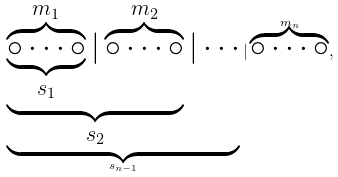Convert formula to latex. <formula><loc_0><loc_0><loc_500><loc_500>\underbrace { \underbrace { \underbrace { \overbrace { \circ \cdots \circ } ^ { m _ { 1 } } } _ { s _ { 1 } } | \overbrace { \circ \cdots \circ } ^ { m _ { 2 } } } _ { s _ { 2 } } | \cdots } _ { s _ { n - 1 } } | \overbrace { \circ \cdots \circ } ^ { m _ { n } } ,</formula> 